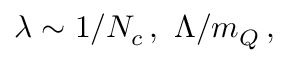Convert formula to latex. <formula><loc_0><loc_0><loc_500><loc_500>\lambda \sim 1 / N _ { c } \, , \, \Lambda / m _ { Q } \, ,</formula> 